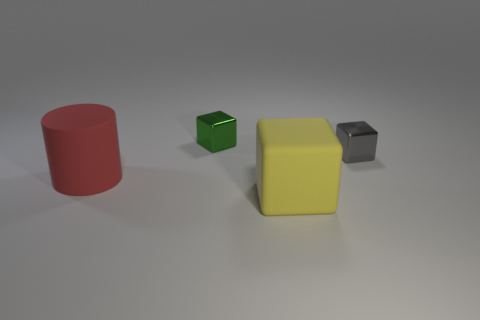What number of matte objects are on the right side of the tiny green object and behind the yellow matte thing?
Offer a very short reply. 0. How many other big cubes have the same material as the large yellow cube?
Offer a terse response. 0. How big is the object that is to the right of the large thing in front of the red object?
Your response must be concise. Small. Are there any other tiny green shiny things of the same shape as the green metal thing?
Offer a very short reply. No. Is the size of the matte thing that is on the right side of the green thing the same as the block left of the large matte block?
Your answer should be very brief. No. Is the number of small gray metallic objects on the left side of the rubber block less than the number of yellow matte objects to the left of the large red object?
Your answer should be very brief. No. The big thing that is to the left of the large rubber block is what color?
Keep it short and to the point. Red. Do the big cube and the cylinder have the same color?
Your answer should be very brief. No. What number of yellow matte objects are behind the big thing that is on the right side of the small cube that is on the left side of the gray object?
Your answer should be very brief. 0. How big is the yellow thing?
Ensure brevity in your answer.  Large. 